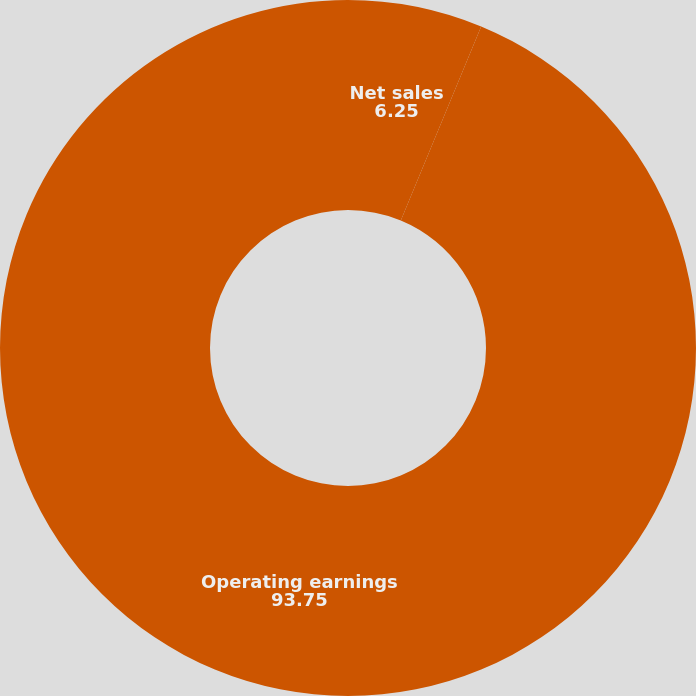Convert chart. <chart><loc_0><loc_0><loc_500><loc_500><pie_chart><fcel>Net sales<fcel>Operating earnings<nl><fcel>6.25%<fcel>93.75%<nl></chart> 